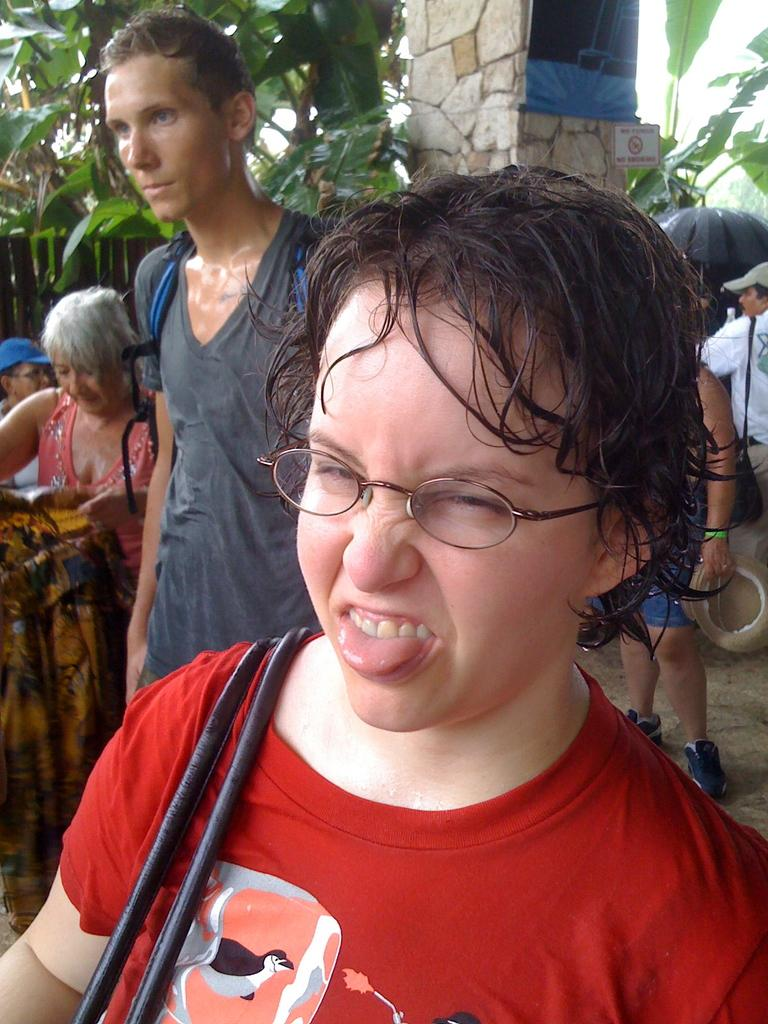How many people can be seen in the image? There are a few people in the image. What can be seen under the people's feet? The ground is visible in the image. What architectural feature is present in the image? There is a pillar in the image. What type of vegetation is present in the image? There are a few trees in the image. What type of barrier is present in the image? There is a fence in the image. What flat, rectangular object is present in the image? There is a board in the image. Can you see a mountain in the background of the image? There is no mountain present in the image. Is there a basketball game taking place in the image? There is no basketball game present in the image. 